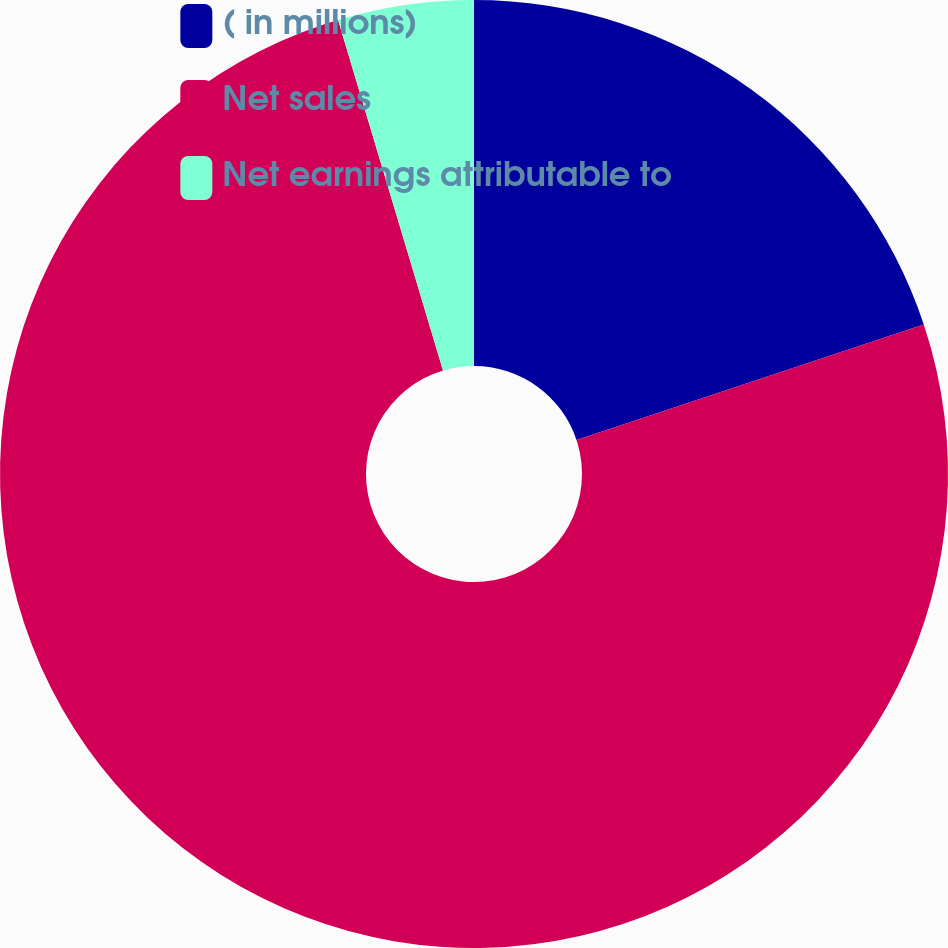<chart> <loc_0><loc_0><loc_500><loc_500><pie_chart><fcel>( in millions)<fcel>Net sales<fcel>Net earnings attributable to<nl><fcel>19.89%<fcel>75.48%<fcel>4.63%<nl></chart> 